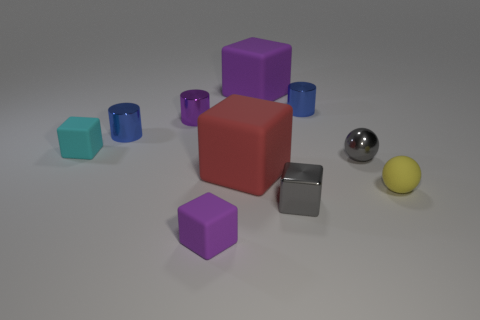What number of other things are made of the same material as the small cyan cube?
Your answer should be very brief. 4. There is a purple rubber object that is on the right side of the large red object; what size is it?
Keep it short and to the point. Large. Do the small shiny ball and the rubber ball have the same color?
Your answer should be very brief. No. What number of tiny things are either blue metallic objects or red rubber things?
Keep it short and to the point. 2. Is there any other thing of the same color as the shiny block?
Your response must be concise. Yes. Are there any small purple matte objects right of the gray block?
Make the answer very short. No. How big is the purple block that is in front of the small ball that is behind the yellow object?
Ensure brevity in your answer.  Small. Are there an equal number of small matte balls that are in front of the large red matte cube and blue things behind the tiny purple metal cylinder?
Offer a very short reply. Yes. There is a small blue cylinder on the right side of the red block; is there a shiny sphere in front of it?
Your response must be concise. Yes. There is a matte object on the right side of the gray metal object that is behind the gray metal block; what number of purple objects are in front of it?
Ensure brevity in your answer.  1. 